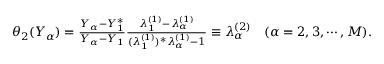<formula> <loc_0><loc_0><loc_500><loc_500>\begin{array} { r } { \theta _ { 2 } ( Y _ { \alpha } ) = \frac { Y _ { \alpha } - Y _ { 1 } ^ { * } } { Y _ { \alpha } - Y _ { 1 } } \frac { \lambda _ { 1 } ^ { ( 1 ) } - \lambda _ { \alpha } ^ { ( 1 ) } } { ( \lambda _ { 1 } ^ { ( 1 ) } ) ^ { * } \lambda _ { \alpha } ^ { ( 1 ) } - 1 } \equiv \lambda _ { \alpha } ^ { ( 2 ) } \quad ( \alpha = 2 , 3 , \cdots , M ) . } \end{array}</formula> 